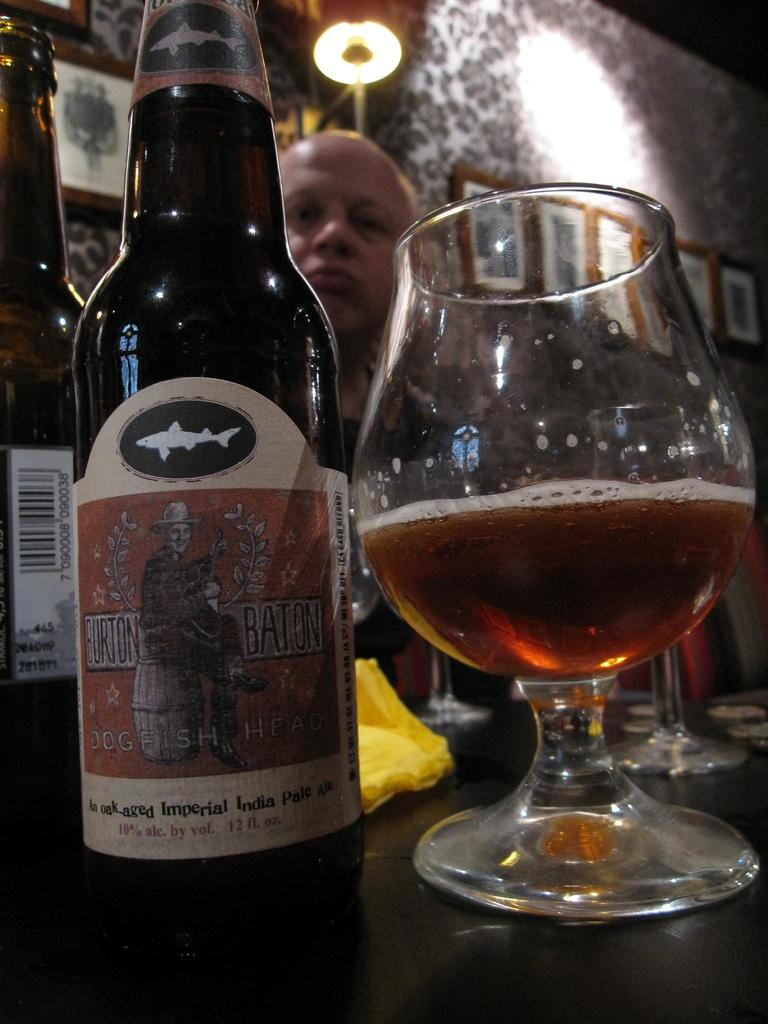What is on the table in the image? There is a glass with liquid and bottles on the table. What is above the table in the image? There is a light on top of the table. Who is present in the image? A person is standing beside the table. What can be seen on the wall in the image? There are different types of pictures on the wall. Reasoning: Let's let's think step by step in order to produce the conversation. We start by identifying the main subjects and objects on the table, which are the glass with liquid and the bottles. Then, we mention the light above the table and the person standing beside it. Finally, we describe the pictures on the wall. Each question is designed to elicit a specific detail about the image that is known from the provided facts. Absurd Question/Answer: How many friends are visible in the image? There is no mention of friends in the image, as it only shows a person standing beside the table. What type of pan is being used by the person in the image? There is no pan present in the image; the person is standing beside the table with a glass, bottles, and pictures on the wall. Can you see the person's feet in the image? There is no mention of the person's feet in the image, as it only shows them standing beside the table. 